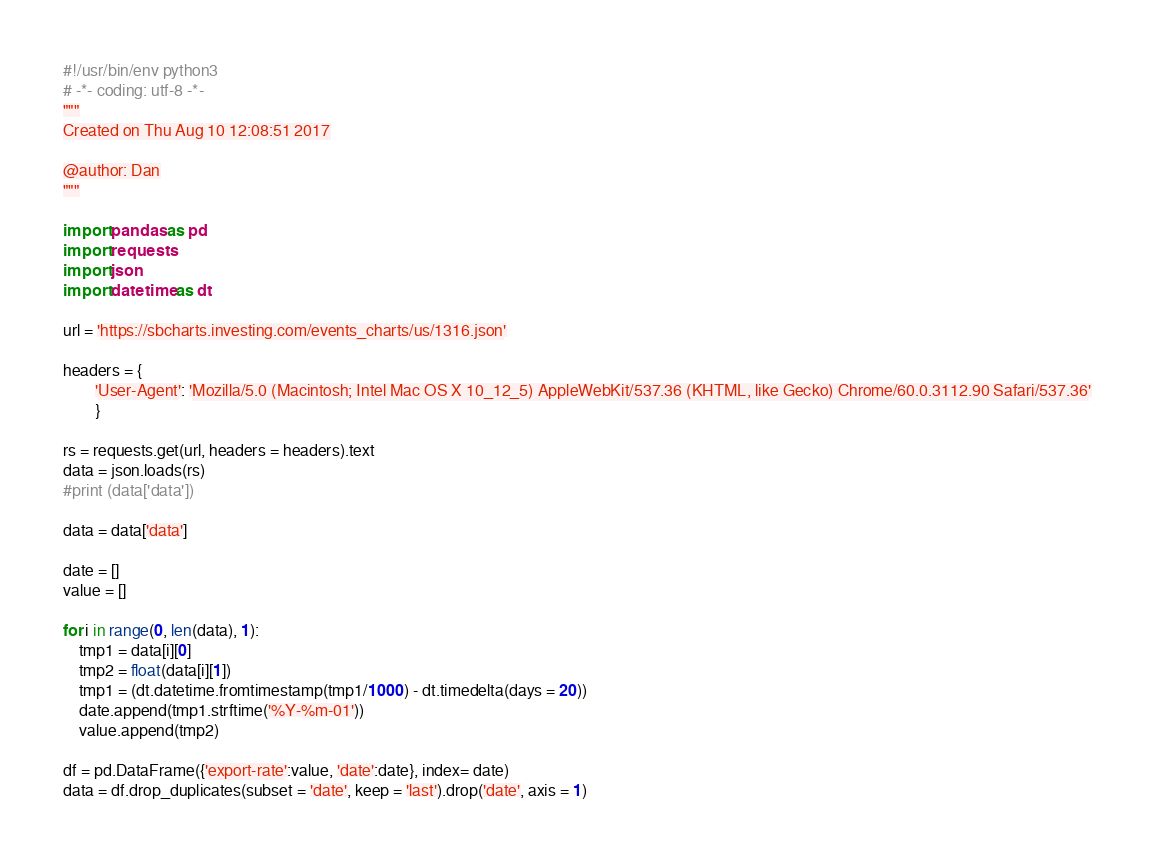<code> <loc_0><loc_0><loc_500><loc_500><_Python_>#!/usr/bin/env python3
# -*- coding: utf-8 -*-
"""
Created on Thu Aug 10 12:08:51 2017

@author: Dan
"""

import pandas as pd
import requests
import json
import datetime as dt

url = 'https://sbcharts.investing.com/events_charts/us/1316.json'

headers = {
        'User-Agent': 'Mozilla/5.0 (Macintosh; Intel Mac OS X 10_12_5) AppleWebKit/537.36 (KHTML, like Gecko) Chrome/60.0.3112.90 Safari/537.36'
        }

rs = requests.get(url, headers = headers).text
data = json.loads(rs)
#print (data['data'])

data = data['data']

date = []
value = []

for i in range(0, len(data), 1):
    tmp1 = data[i][0]
    tmp2 = float(data[i][1])
    tmp1 = (dt.datetime.fromtimestamp(tmp1/1000) - dt.timedelta(days = 20))
    date.append(tmp1.strftime('%Y-%m-01'))
    value.append(tmp2)

df = pd.DataFrame({'export-rate':value, 'date':date}, index= date)
data = df.drop_duplicates(subset = 'date', keep = 'last').drop('date', axis = 1)

</code> 